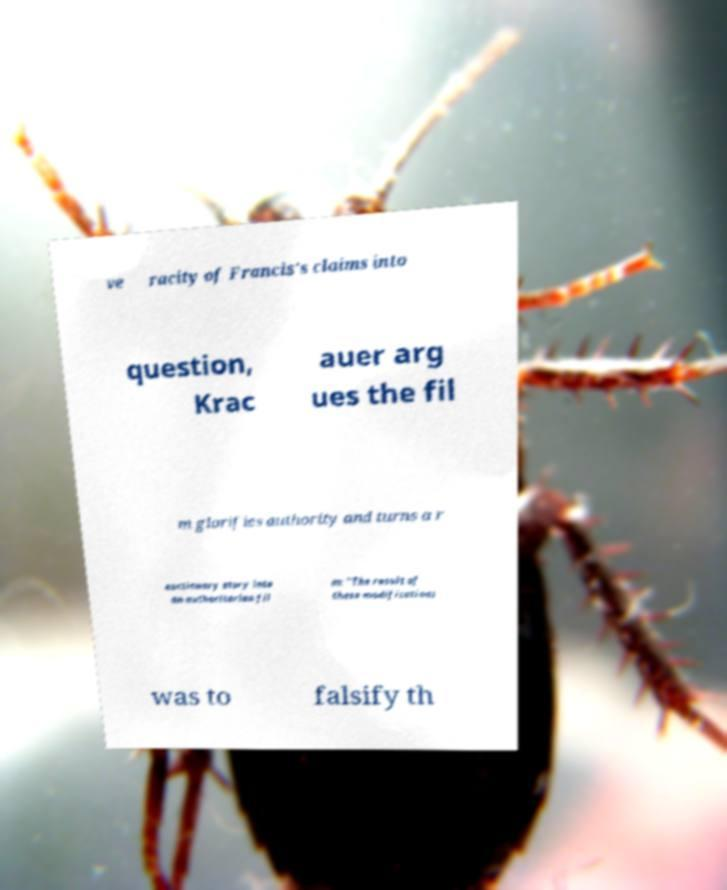What messages or text are displayed in this image? I need them in a readable, typed format. ve racity of Francis's claims into question, Krac auer arg ues the fil m glorifies authority and turns a r eactionary story into an authoritarian fil m: "The result of these modifications was to falsify th 